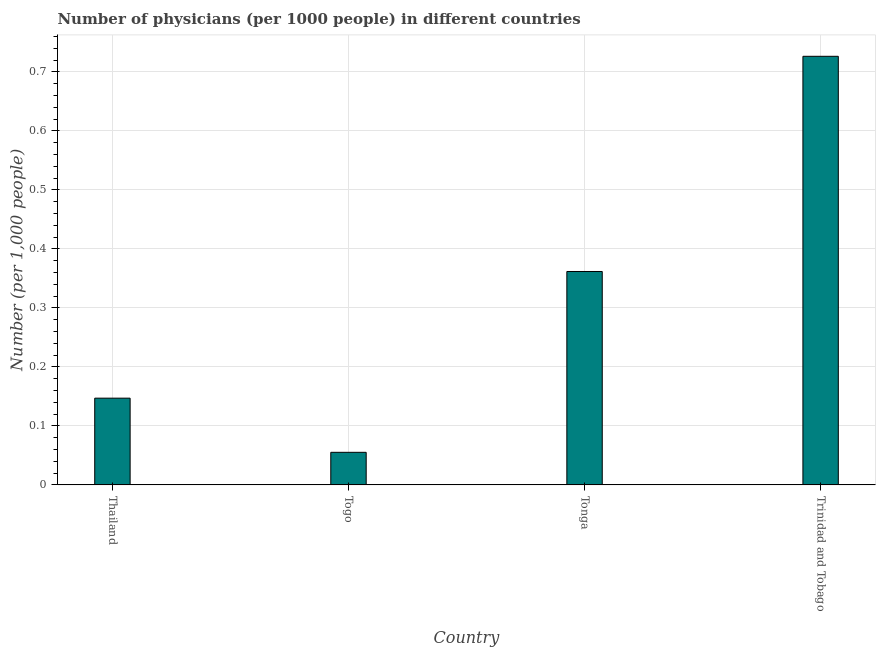Does the graph contain grids?
Provide a short and direct response. Yes. What is the title of the graph?
Keep it short and to the point. Number of physicians (per 1000 people) in different countries. What is the label or title of the X-axis?
Provide a short and direct response. Country. What is the label or title of the Y-axis?
Keep it short and to the point. Number (per 1,0 people). What is the number of physicians in Thailand?
Your answer should be compact. 0.15. Across all countries, what is the maximum number of physicians?
Your response must be concise. 0.73. Across all countries, what is the minimum number of physicians?
Provide a short and direct response. 0.06. In which country was the number of physicians maximum?
Offer a very short reply. Trinidad and Tobago. In which country was the number of physicians minimum?
Your answer should be compact. Togo. What is the sum of the number of physicians?
Your response must be concise. 1.29. What is the difference between the number of physicians in Tonga and Trinidad and Tobago?
Ensure brevity in your answer.  -0.36. What is the average number of physicians per country?
Provide a succinct answer. 0.32. What is the median number of physicians?
Ensure brevity in your answer.  0.25. In how many countries, is the number of physicians greater than 0.58 ?
Offer a very short reply. 1. What is the ratio of the number of physicians in Thailand to that in Trinidad and Tobago?
Your response must be concise. 0.2. Is the number of physicians in Tonga less than that in Trinidad and Tobago?
Your response must be concise. Yes. What is the difference between the highest and the second highest number of physicians?
Keep it short and to the point. 0.36. What is the difference between the highest and the lowest number of physicians?
Keep it short and to the point. 0.67. In how many countries, is the number of physicians greater than the average number of physicians taken over all countries?
Your answer should be very brief. 2. Are the values on the major ticks of Y-axis written in scientific E-notation?
Your answer should be compact. No. What is the Number (per 1,000 people) of Thailand?
Offer a very short reply. 0.15. What is the Number (per 1,000 people) of Togo?
Provide a succinct answer. 0.06. What is the Number (per 1,000 people) of Tonga?
Provide a succinct answer. 0.36. What is the Number (per 1,000 people) of Trinidad and Tobago?
Offer a terse response. 0.73. What is the difference between the Number (per 1,000 people) in Thailand and Togo?
Keep it short and to the point. 0.09. What is the difference between the Number (per 1,000 people) in Thailand and Tonga?
Give a very brief answer. -0.21. What is the difference between the Number (per 1,000 people) in Thailand and Trinidad and Tobago?
Give a very brief answer. -0.58. What is the difference between the Number (per 1,000 people) in Togo and Tonga?
Your response must be concise. -0.31. What is the difference between the Number (per 1,000 people) in Togo and Trinidad and Tobago?
Give a very brief answer. -0.67. What is the difference between the Number (per 1,000 people) in Tonga and Trinidad and Tobago?
Provide a short and direct response. -0.36. What is the ratio of the Number (per 1,000 people) in Thailand to that in Togo?
Ensure brevity in your answer.  2.66. What is the ratio of the Number (per 1,000 people) in Thailand to that in Tonga?
Your answer should be compact. 0.41. What is the ratio of the Number (per 1,000 people) in Thailand to that in Trinidad and Tobago?
Your response must be concise. 0.2. What is the ratio of the Number (per 1,000 people) in Togo to that in Tonga?
Make the answer very short. 0.15. What is the ratio of the Number (per 1,000 people) in Togo to that in Trinidad and Tobago?
Ensure brevity in your answer.  0.08. What is the ratio of the Number (per 1,000 people) in Tonga to that in Trinidad and Tobago?
Offer a very short reply. 0.5. 